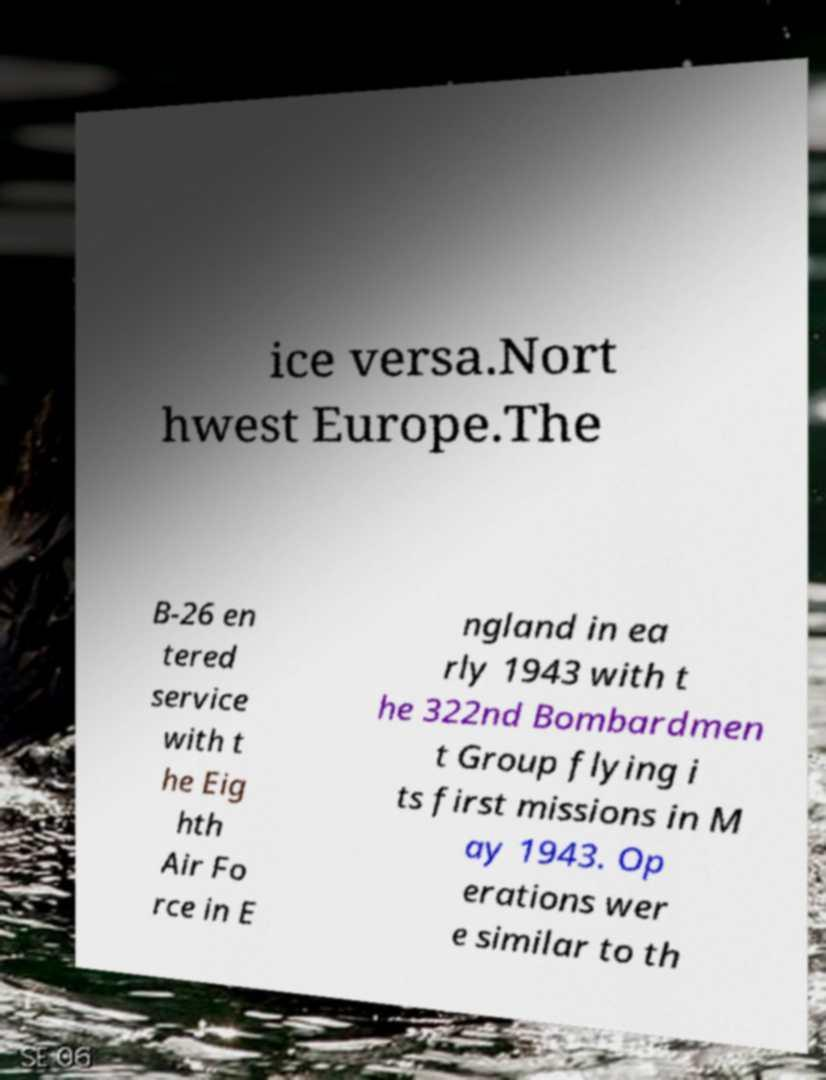Please identify and transcribe the text found in this image. ice versa.Nort hwest Europe.The B-26 en tered service with t he Eig hth Air Fo rce in E ngland in ea rly 1943 with t he 322nd Bombardmen t Group flying i ts first missions in M ay 1943. Op erations wer e similar to th 